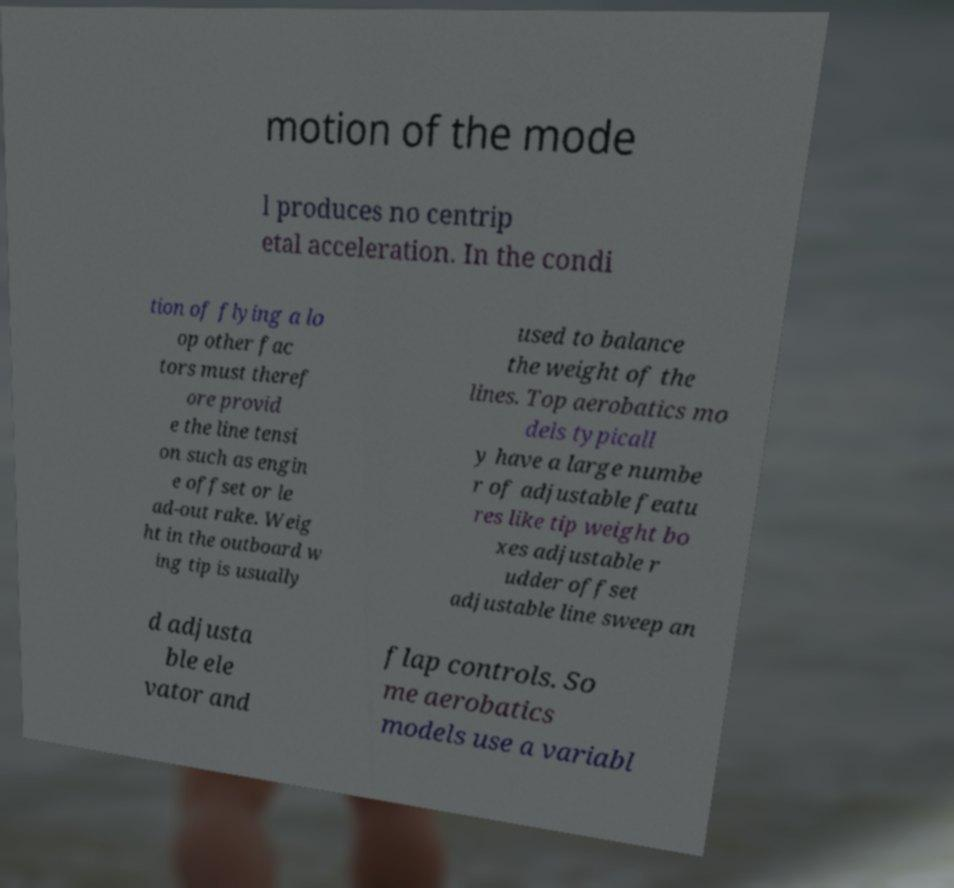Could you assist in decoding the text presented in this image and type it out clearly? motion of the mode l produces no centrip etal acceleration. In the condi tion of flying a lo op other fac tors must theref ore provid e the line tensi on such as engin e offset or le ad-out rake. Weig ht in the outboard w ing tip is usually used to balance the weight of the lines. Top aerobatics mo dels typicall y have a large numbe r of adjustable featu res like tip weight bo xes adjustable r udder offset adjustable line sweep an d adjusta ble ele vator and flap controls. So me aerobatics models use a variabl 